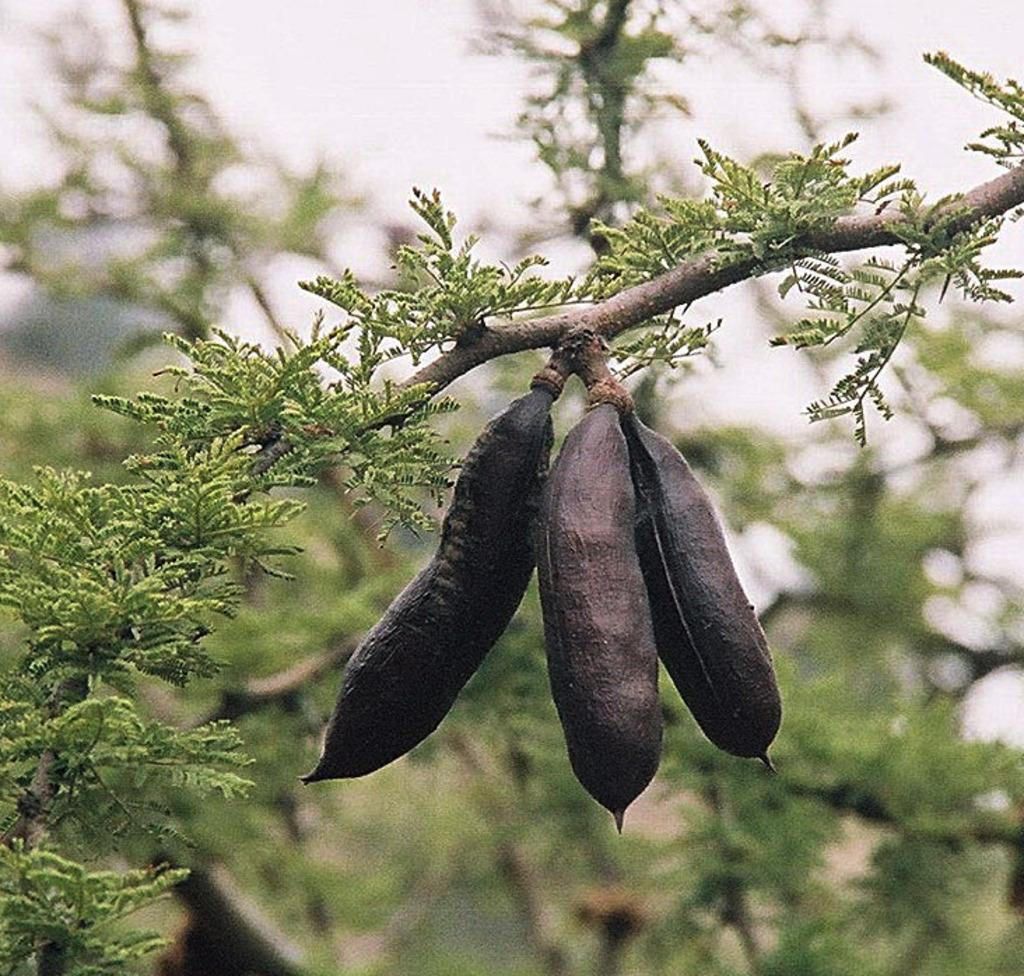How many black colored fruits are in the image? There are three black colored fruits in the image. Where are the fruits located? The fruits are on a tree. What is the color of the tree? The tree is green and brown in color. What can be seen in the background of the image? The background of the image is blurry, and there are trees and the sky visible. Can you tell me how many sisters are protesting in the image? There are no sisters or protest present in the image; it features three black colored fruits on a tree. 